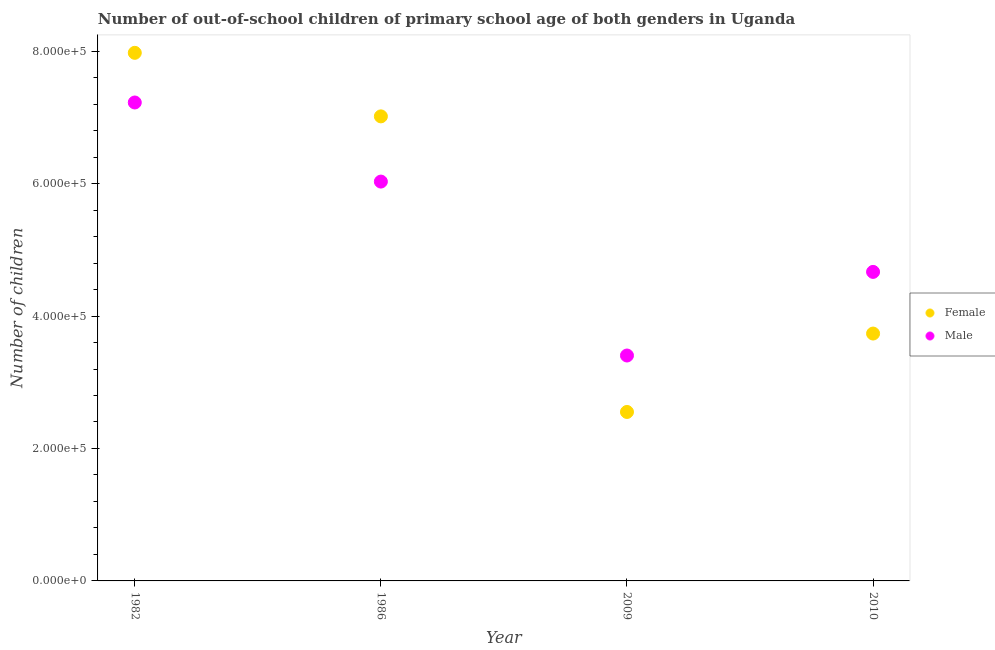How many different coloured dotlines are there?
Your response must be concise. 2. Is the number of dotlines equal to the number of legend labels?
Offer a very short reply. Yes. What is the number of female out-of-school students in 1982?
Your response must be concise. 7.97e+05. Across all years, what is the maximum number of male out-of-school students?
Your response must be concise. 7.22e+05. Across all years, what is the minimum number of female out-of-school students?
Give a very brief answer. 2.55e+05. In which year was the number of male out-of-school students minimum?
Give a very brief answer. 2009. What is the total number of male out-of-school students in the graph?
Keep it short and to the point. 2.13e+06. What is the difference between the number of female out-of-school students in 1986 and that in 2010?
Keep it short and to the point. 3.28e+05. What is the difference between the number of female out-of-school students in 1982 and the number of male out-of-school students in 1986?
Make the answer very short. 1.94e+05. What is the average number of male out-of-school students per year?
Offer a very short reply. 5.33e+05. In the year 2009, what is the difference between the number of male out-of-school students and number of female out-of-school students?
Ensure brevity in your answer.  8.52e+04. In how many years, is the number of male out-of-school students greater than 280000?
Provide a short and direct response. 4. What is the ratio of the number of female out-of-school students in 1982 to that in 2010?
Provide a short and direct response. 2.13. Is the number of male out-of-school students in 2009 less than that in 2010?
Provide a succinct answer. Yes. What is the difference between the highest and the second highest number of male out-of-school students?
Your response must be concise. 1.19e+05. What is the difference between the highest and the lowest number of female out-of-school students?
Your response must be concise. 5.42e+05. Is the sum of the number of male out-of-school students in 2009 and 2010 greater than the maximum number of female out-of-school students across all years?
Provide a succinct answer. Yes. Are the values on the major ticks of Y-axis written in scientific E-notation?
Offer a very short reply. Yes. Where does the legend appear in the graph?
Make the answer very short. Center right. How are the legend labels stacked?
Ensure brevity in your answer.  Vertical. What is the title of the graph?
Provide a succinct answer. Number of out-of-school children of primary school age of both genders in Uganda. What is the label or title of the Y-axis?
Keep it short and to the point. Number of children. What is the Number of children of Female in 1982?
Offer a very short reply. 7.97e+05. What is the Number of children in Male in 1982?
Your answer should be very brief. 7.22e+05. What is the Number of children in Female in 1986?
Offer a very short reply. 7.02e+05. What is the Number of children in Male in 1986?
Your answer should be compact. 6.03e+05. What is the Number of children of Female in 2009?
Make the answer very short. 2.55e+05. What is the Number of children of Male in 2009?
Your answer should be compact. 3.40e+05. What is the Number of children in Female in 2010?
Give a very brief answer. 3.74e+05. What is the Number of children of Male in 2010?
Offer a very short reply. 4.67e+05. Across all years, what is the maximum Number of children of Female?
Offer a terse response. 7.97e+05. Across all years, what is the maximum Number of children of Male?
Give a very brief answer. 7.22e+05. Across all years, what is the minimum Number of children of Female?
Keep it short and to the point. 2.55e+05. Across all years, what is the minimum Number of children of Male?
Provide a succinct answer. 3.40e+05. What is the total Number of children in Female in the graph?
Make the answer very short. 2.13e+06. What is the total Number of children in Male in the graph?
Provide a succinct answer. 2.13e+06. What is the difference between the Number of children of Female in 1982 and that in 1986?
Offer a terse response. 9.60e+04. What is the difference between the Number of children in Male in 1982 and that in 1986?
Your response must be concise. 1.19e+05. What is the difference between the Number of children in Female in 1982 and that in 2009?
Give a very brief answer. 5.42e+05. What is the difference between the Number of children of Male in 1982 and that in 2009?
Ensure brevity in your answer.  3.82e+05. What is the difference between the Number of children of Female in 1982 and that in 2010?
Make the answer very short. 4.24e+05. What is the difference between the Number of children of Male in 1982 and that in 2010?
Your answer should be very brief. 2.56e+05. What is the difference between the Number of children in Female in 1986 and that in 2009?
Provide a short and direct response. 4.46e+05. What is the difference between the Number of children of Male in 1986 and that in 2009?
Give a very brief answer. 2.63e+05. What is the difference between the Number of children in Female in 1986 and that in 2010?
Ensure brevity in your answer.  3.28e+05. What is the difference between the Number of children in Male in 1986 and that in 2010?
Ensure brevity in your answer.  1.36e+05. What is the difference between the Number of children in Female in 2009 and that in 2010?
Make the answer very short. -1.18e+05. What is the difference between the Number of children in Male in 2009 and that in 2010?
Offer a terse response. -1.26e+05. What is the difference between the Number of children of Female in 1982 and the Number of children of Male in 1986?
Make the answer very short. 1.94e+05. What is the difference between the Number of children of Female in 1982 and the Number of children of Male in 2009?
Your answer should be compact. 4.57e+05. What is the difference between the Number of children in Female in 1982 and the Number of children in Male in 2010?
Offer a terse response. 3.31e+05. What is the difference between the Number of children in Female in 1986 and the Number of children in Male in 2009?
Provide a succinct answer. 3.61e+05. What is the difference between the Number of children in Female in 1986 and the Number of children in Male in 2010?
Provide a succinct answer. 2.35e+05. What is the difference between the Number of children in Female in 2009 and the Number of children in Male in 2010?
Give a very brief answer. -2.12e+05. What is the average Number of children in Female per year?
Provide a succinct answer. 5.32e+05. What is the average Number of children in Male per year?
Provide a succinct answer. 5.33e+05. In the year 1982, what is the difference between the Number of children in Female and Number of children in Male?
Ensure brevity in your answer.  7.50e+04. In the year 1986, what is the difference between the Number of children in Female and Number of children in Male?
Offer a terse response. 9.85e+04. In the year 2009, what is the difference between the Number of children of Female and Number of children of Male?
Offer a very short reply. -8.52e+04. In the year 2010, what is the difference between the Number of children of Female and Number of children of Male?
Your answer should be compact. -9.31e+04. What is the ratio of the Number of children of Female in 1982 to that in 1986?
Offer a terse response. 1.14. What is the ratio of the Number of children in Male in 1982 to that in 1986?
Offer a very short reply. 1.2. What is the ratio of the Number of children in Female in 1982 to that in 2009?
Offer a terse response. 3.13. What is the ratio of the Number of children in Male in 1982 to that in 2009?
Offer a very short reply. 2.12. What is the ratio of the Number of children of Female in 1982 to that in 2010?
Your answer should be very brief. 2.13. What is the ratio of the Number of children in Male in 1982 to that in 2010?
Provide a short and direct response. 1.55. What is the ratio of the Number of children in Female in 1986 to that in 2009?
Give a very brief answer. 2.75. What is the ratio of the Number of children in Male in 1986 to that in 2009?
Give a very brief answer. 1.77. What is the ratio of the Number of children in Female in 1986 to that in 2010?
Provide a short and direct response. 1.88. What is the ratio of the Number of children of Male in 1986 to that in 2010?
Provide a succinct answer. 1.29. What is the ratio of the Number of children in Female in 2009 to that in 2010?
Provide a short and direct response. 0.68. What is the ratio of the Number of children in Male in 2009 to that in 2010?
Ensure brevity in your answer.  0.73. What is the difference between the highest and the second highest Number of children in Female?
Offer a very short reply. 9.60e+04. What is the difference between the highest and the second highest Number of children in Male?
Keep it short and to the point. 1.19e+05. What is the difference between the highest and the lowest Number of children in Female?
Offer a very short reply. 5.42e+05. What is the difference between the highest and the lowest Number of children in Male?
Your answer should be very brief. 3.82e+05. 